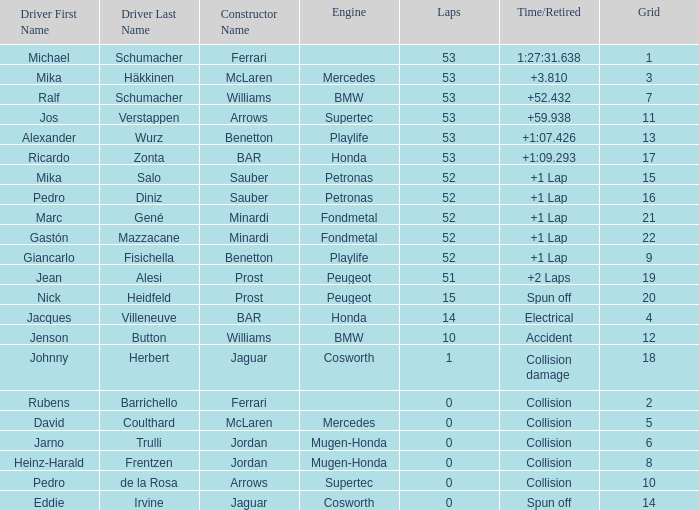How many rounds did ricardo zonta finish? 53.0. 